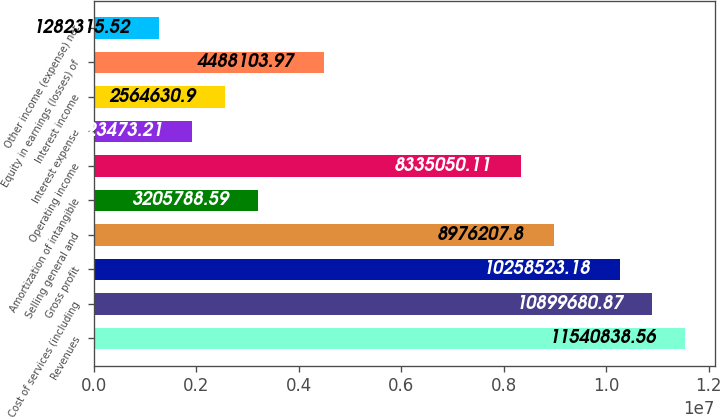Convert chart to OTSL. <chart><loc_0><loc_0><loc_500><loc_500><bar_chart><fcel>Revenues<fcel>Cost of services (including<fcel>Gross profit<fcel>Selling general and<fcel>Amortization of intangible<fcel>Operating income<fcel>Interest expense<fcel>Interest income<fcel>Equity in earnings (losses) of<fcel>Other income (expense) net<nl><fcel>1.15408e+07<fcel>1.08997e+07<fcel>1.02585e+07<fcel>8.97621e+06<fcel>3.20579e+06<fcel>8.33505e+06<fcel>1.92347e+06<fcel>2.56463e+06<fcel>4.4881e+06<fcel>1.28232e+06<nl></chart> 